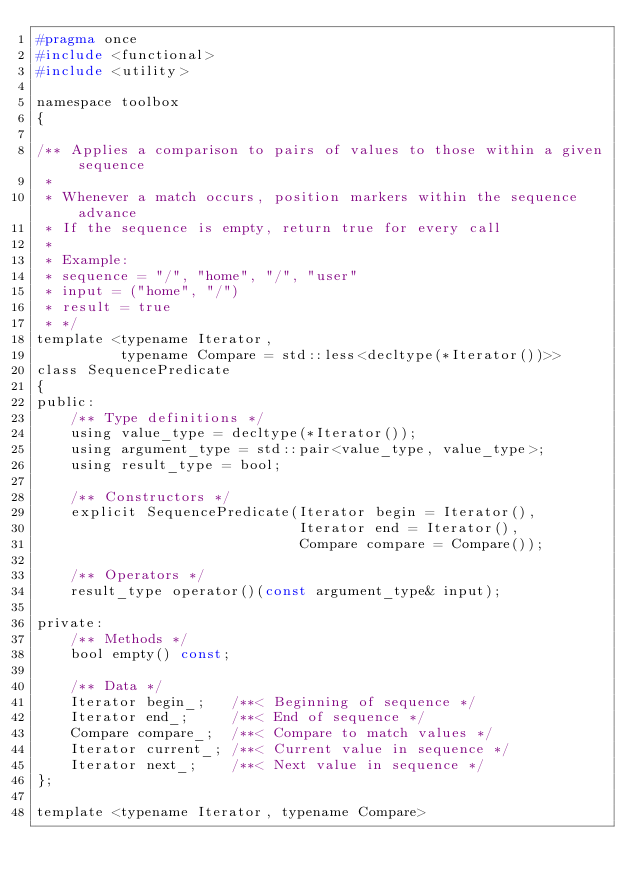Convert code to text. <code><loc_0><loc_0><loc_500><loc_500><_C_>#pragma once
#include <functional>
#include <utility>

namespace toolbox
{

/** Applies a comparison to pairs of values to those within a given sequence
 *
 * Whenever a match occurs, position markers within the sequence advance
 * If the sequence is empty, return true for every call
 *
 * Example:
 * sequence = "/", "home", "/", "user"
 * input = ("home", "/")
 * result = true
 * */
template <typename Iterator,
          typename Compare = std::less<decltype(*Iterator())>>
class SequencePredicate
{
public:
    /** Type definitions */
    using value_type = decltype(*Iterator());
    using argument_type = std::pair<value_type, value_type>;
    using result_type = bool;

    /** Constructors */
    explicit SequencePredicate(Iterator begin = Iterator(),
                               Iterator end = Iterator(),
                               Compare compare = Compare());

    /** Operators */
    result_type operator()(const argument_type& input);

private:
    /** Methods */
    bool empty() const;

    /** Data */
    Iterator begin_;   /**< Beginning of sequence */
    Iterator end_;     /**< End of sequence */
    Compare compare_;  /**< Compare to match values */
    Iterator current_; /**< Current value in sequence */
    Iterator next_;    /**< Next value in sequence */
};

template <typename Iterator, typename Compare></code> 